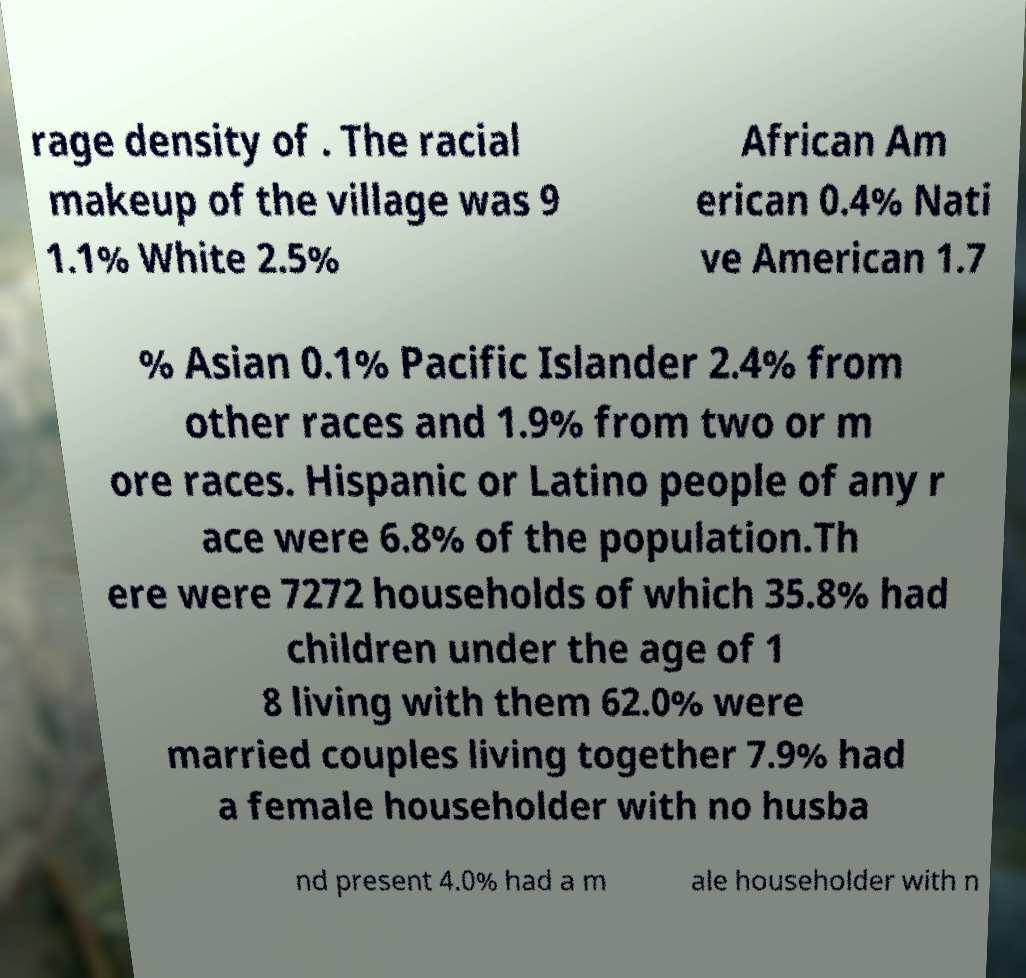What messages or text are displayed in this image? I need them in a readable, typed format. rage density of . The racial makeup of the village was 9 1.1% White 2.5% African Am erican 0.4% Nati ve American 1.7 % Asian 0.1% Pacific Islander 2.4% from other races and 1.9% from two or m ore races. Hispanic or Latino people of any r ace were 6.8% of the population.Th ere were 7272 households of which 35.8% had children under the age of 1 8 living with them 62.0% were married couples living together 7.9% had a female householder with no husba nd present 4.0% had a m ale householder with n 